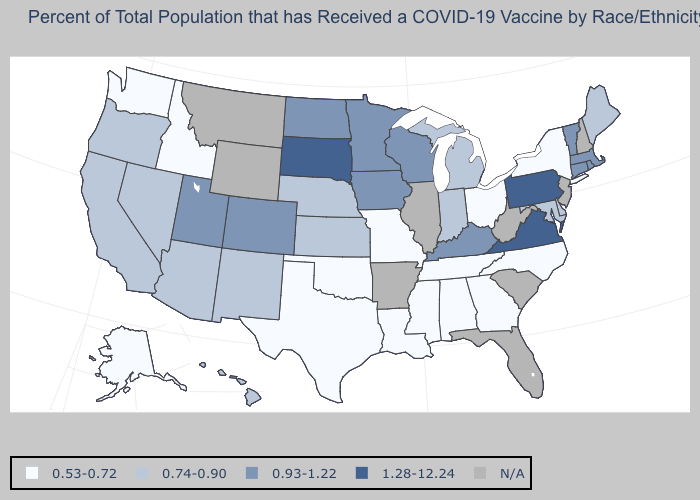What is the value of Colorado?
Short answer required. 0.93-1.22. Name the states that have a value in the range 0.53-0.72?
Give a very brief answer. Alabama, Alaska, Georgia, Idaho, Louisiana, Mississippi, Missouri, New York, North Carolina, Ohio, Oklahoma, Tennessee, Texas, Washington. What is the value of Massachusetts?
Quick response, please. 0.93-1.22. Is the legend a continuous bar?
Short answer required. No. Which states have the lowest value in the USA?
Short answer required. Alabama, Alaska, Georgia, Idaho, Louisiana, Mississippi, Missouri, New York, North Carolina, Ohio, Oklahoma, Tennessee, Texas, Washington. Does Pennsylvania have the highest value in the USA?
Give a very brief answer. Yes. Name the states that have a value in the range 0.53-0.72?
Answer briefly. Alabama, Alaska, Georgia, Idaho, Louisiana, Mississippi, Missouri, New York, North Carolina, Ohio, Oklahoma, Tennessee, Texas, Washington. What is the highest value in the South ?
Answer briefly. 1.28-12.24. Does Pennsylvania have the lowest value in the USA?
Write a very short answer. No. Name the states that have a value in the range 0.93-1.22?
Answer briefly. Colorado, Connecticut, Iowa, Kentucky, Massachusetts, Minnesota, North Dakota, Rhode Island, Utah, Vermont, Wisconsin. Which states have the highest value in the USA?
Concise answer only. Pennsylvania, South Dakota, Virginia. Which states have the lowest value in the MidWest?
Write a very short answer. Missouri, Ohio. What is the highest value in the MidWest ?
Give a very brief answer. 1.28-12.24. What is the highest value in states that border Massachusetts?
Quick response, please. 0.93-1.22. 